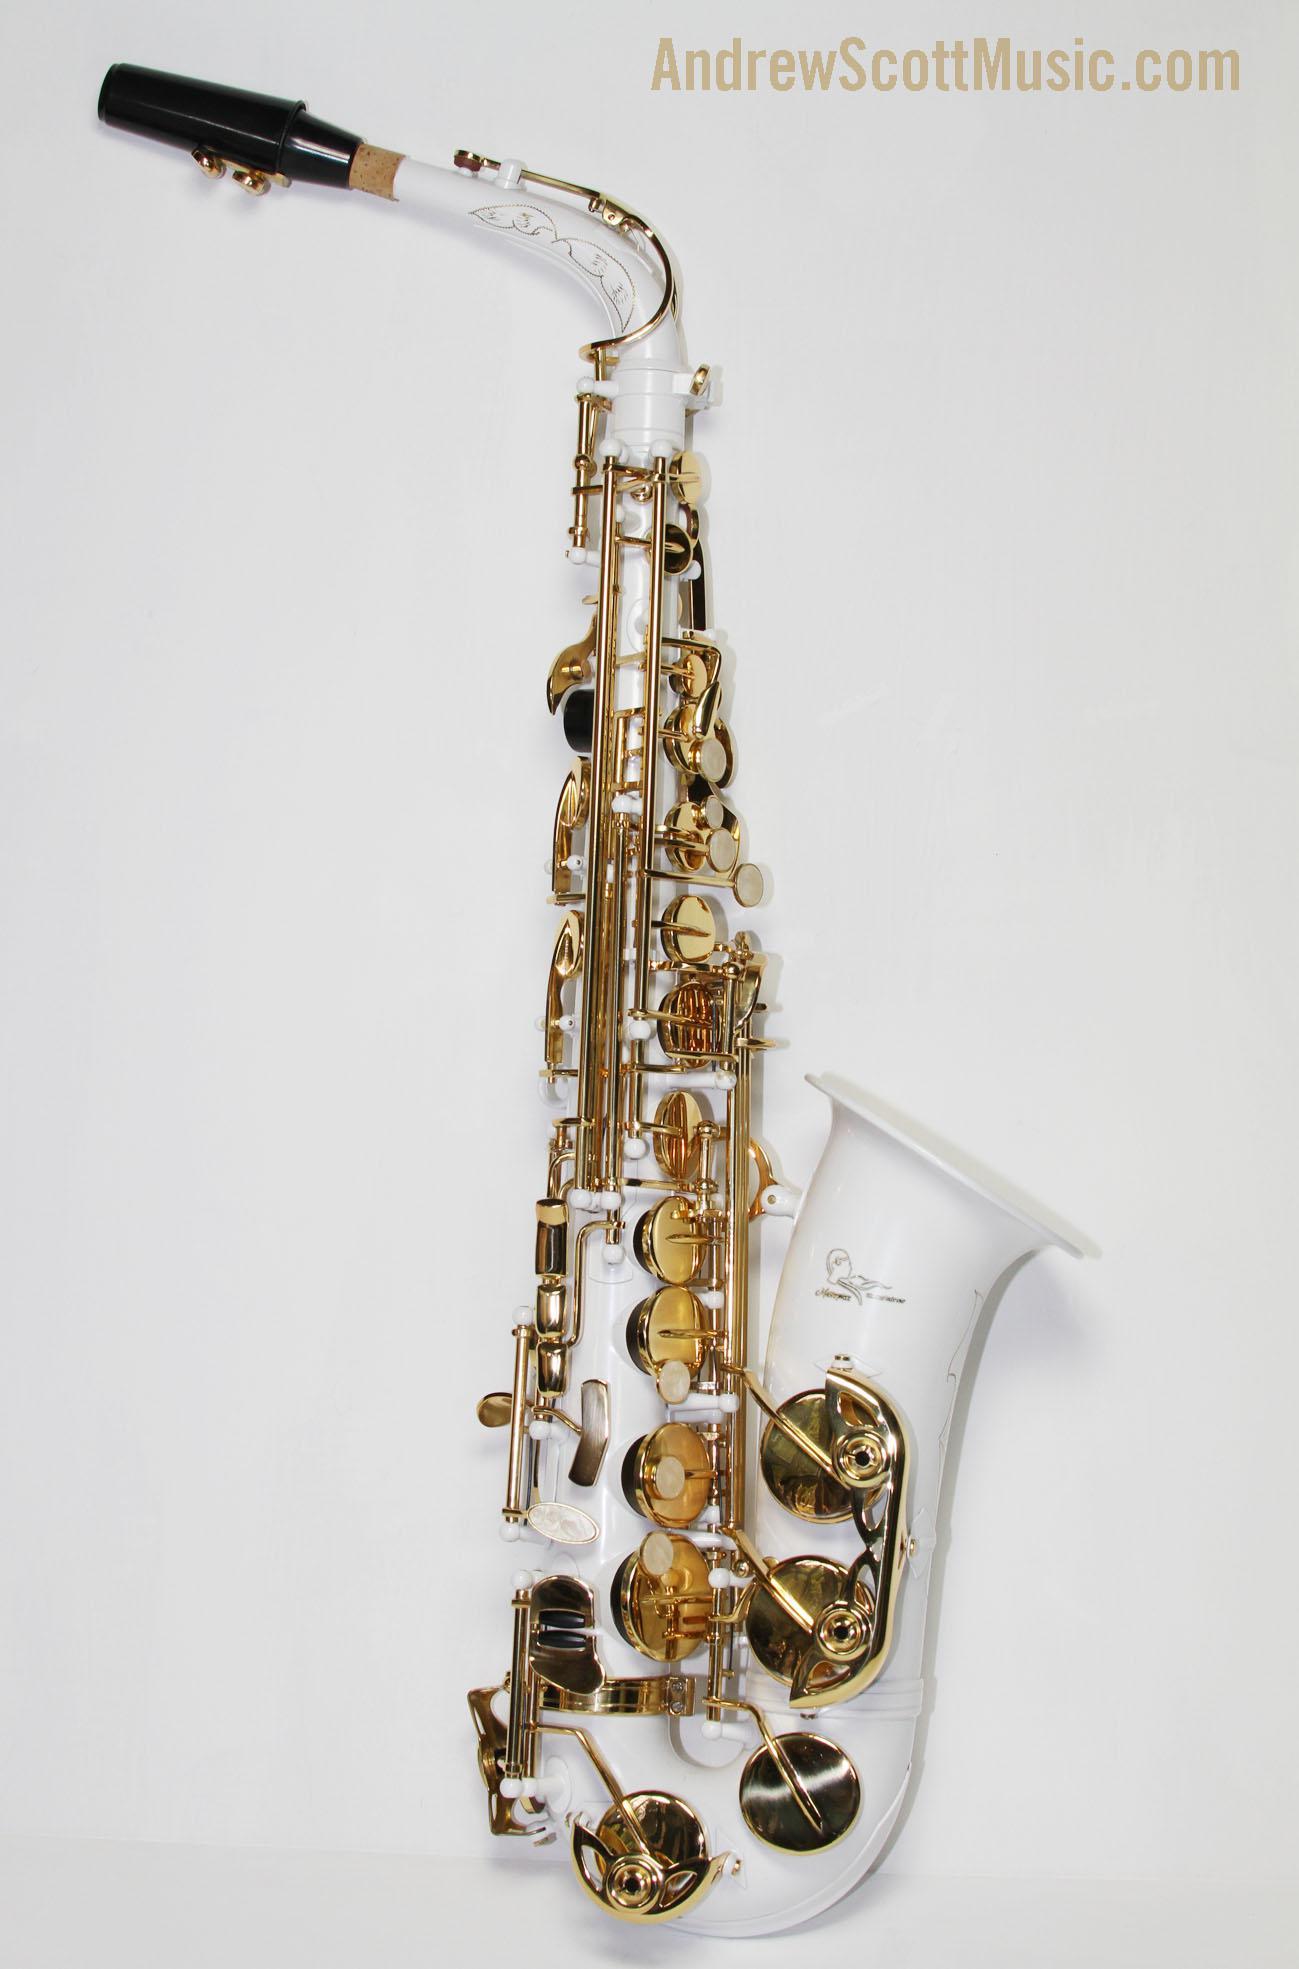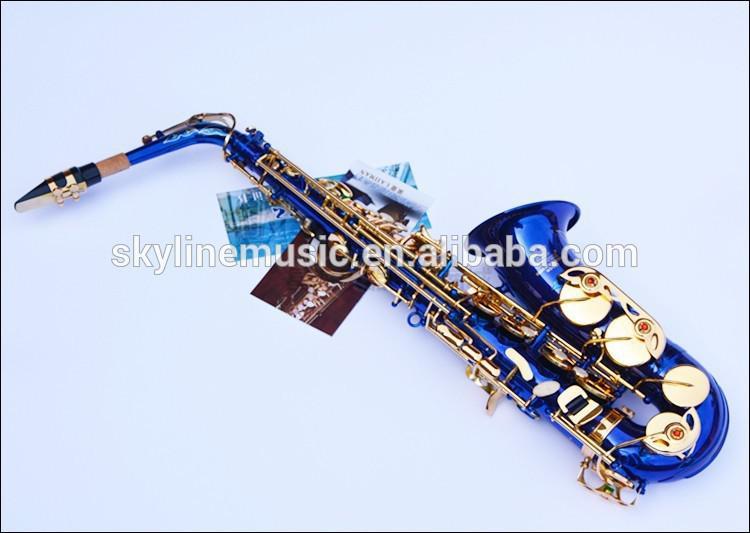The first image is the image on the left, the second image is the image on the right. Analyze the images presented: Is the assertion "An image shows just one view of one bright blue saxophone with brass-colored buttons." valid? Answer yes or no. Yes. The first image is the image on the left, the second image is the image on the right. Examine the images to the left and right. Is the description "There are more instruments shown in the image on the left." accurate? Answer yes or no. No. 